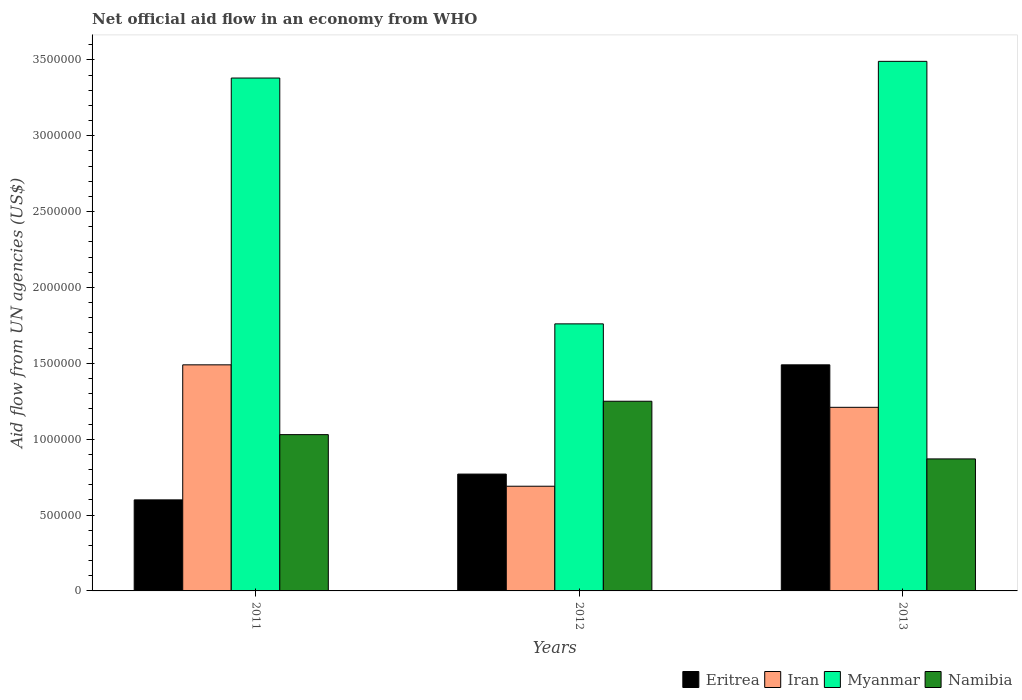Are the number of bars on each tick of the X-axis equal?
Give a very brief answer. Yes. How many bars are there on the 2nd tick from the left?
Provide a succinct answer. 4. How many bars are there on the 3rd tick from the right?
Offer a terse response. 4. In how many cases, is the number of bars for a given year not equal to the number of legend labels?
Ensure brevity in your answer.  0. What is the net official aid flow in Myanmar in 2013?
Your response must be concise. 3.49e+06. Across all years, what is the maximum net official aid flow in Myanmar?
Offer a very short reply. 3.49e+06. Across all years, what is the minimum net official aid flow in Iran?
Your answer should be very brief. 6.90e+05. In which year was the net official aid flow in Eritrea maximum?
Keep it short and to the point. 2013. What is the total net official aid flow in Namibia in the graph?
Give a very brief answer. 3.15e+06. What is the difference between the net official aid flow in Namibia in 2011 and that in 2012?
Keep it short and to the point. -2.20e+05. What is the average net official aid flow in Myanmar per year?
Keep it short and to the point. 2.88e+06. In the year 2012, what is the difference between the net official aid flow in Eritrea and net official aid flow in Myanmar?
Provide a short and direct response. -9.90e+05. In how many years, is the net official aid flow in Iran greater than 2800000 US$?
Give a very brief answer. 0. What is the ratio of the net official aid flow in Eritrea in 2012 to that in 2013?
Your response must be concise. 0.52. Is the difference between the net official aid flow in Eritrea in 2011 and 2012 greater than the difference between the net official aid flow in Myanmar in 2011 and 2012?
Your response must be concise. No. What is the difference between the highest and the lowest net official aid flow in Eritrea?
Offer a terse response. 8.90e+05. Is the sum of the net official aid flow in Namibia in 2011 and 2012 greater than the maximum net official aid flow in Iran across all years?
Provide a short and direct response. Yes. What does the 1st bar from the left in 2013 represents?
Your answer should be very brief. Eritrea. What does the 3rd bar from the right in 2013 represents?
Your response must be concise. Iran. Is it the case that in every year, the sum of the net official aid flow in Namibia and net official aid flow in Myanmar is greater than the net official aid flow in Iran?
Make the answer very short. Yes. How many bars are there?
Your answer should be compact. 12. Are all the bars in the graph horizontal?
Provide a succinct answer. No. How many years are there in the graph?
Offer a very short reply. 3. Does the graph contain any zero values?
Give a very brief answer. No. Does the graph contain grids?
Make the answer very short. No. How many legend labels are there?
Give a very brief answer. 4. How are the legend labels stacked?
Your answer should be very brief. Horizontal. What is the title of the graph?
Your response must be concise. Net official aid flow in an economy from WHO. What is the label or title of the Y-axis?
Your answer should be very brief. Aid flow from UN agencies (US$). What is the Aid flow from UN agencies (US$) of Iran in 2011?
Provide a short and direct response. 1.49e+06. What is the Aid flow from UN agencies (US$) in Myanmar in 2011?
Ensure brevity in your answer.  3.38e+06. What is the Aid flow from UN agencies (US$) of Namibia in 2011?
Your response must be concise. 1.03e+06. What is the Aid flow from UN agencies (US$) of Eritrea in 2012?
Your response must be concise. 7.70e+05. What is the Aid flow from UN agencies (US$) in Iran in 2012?
Offer a very short reply. 6.90e+05. What is the Aid flow from UN agencies (US$) of Myanmar in 2012?
Your answer should be compact. 1.76e+06. What is the Aid flow from UN agencies (US$) in Namibia in 2012?
Your answer should be very brief. 1.25e+06. What is the Aid flow from UN agencies (US$) of Eritrea in 2013?
Give a very brief answer. 1.49e+06. What is the Aid flow from UN agencies (US$) in Iran in 2013?
Provide a succinct answer. 1.21e+06. What is the Aid flow from UN agencies (US$) in Myanmar in 2013?
Offer a terse response. 3.49e+06. What is the Aid flow from UN agencies (US$) in Namibia in 2013?
Offer a very short reply. 8.70e+05. Across all years, what is the maximum Aid flow from UN agencies (US$) in Eritrea?
Ensure brevity in your answer.  1.49e+06. Across all years, what is the maximum Aid flow from UN agencies (US$) in Iran?
Provide a short and direct response. 1.49e+06. Across all years, what is the maximum Aid flow from UN agencies (US$) of Myanmar?
Offer a terse response. 3.49e+06. Across all years, what is the maximum Aid flow from UN agencies (US$) in Namibia?
Offer a very short reply. 1.25e+06. Across all years, what is the minimum Aid flow from UN agencies (US$) in Iran?
Offer a very short reply. 6.90e+05. Across all years, what is the minimum Aid flow from UN agencies (US$) in Myanmar?
Your answer should be very brief. 1.76e+06. Across all years, what is the minimum Aid flow from UN agencies (US$) in Namibia?
Offer a very short reply. 8.70e+05. What is the total Aid flow from UN agencies (US$) in Eritrea in the graph?
Your answer should be compact. 2.86e+06. What is the total Aid flow from UN agencies (US$) in Iran in the graph?
Provide a short and direct response. 3.39e+06. What is the total Aid flow from UN agencies (US$) in Myanmar in the graph?
Your answer should be very brief. 8.63e+06. What is the total Aid flow from UN agencies (US$) of Namibia in the graph?
Make the answer very short. 3.15e+06. What is the difference between the Aid flow from UN agencies (US$) of Iran in 2011 and that in 2012?
Your response must be concise. 8.00e+05. What is the difference between the Aid flow from UN agencies (US$) of Myanmar in 2011 and that in 2012?
Offer a terse response. 1.62e+06. What is the difference between the Aid flow from UN agencies (US$) in Eritrea in 2011 and that in 2013?
Your response must be concise. -8.90e+05. What is the difference between the Aid flow from UN agencies (US$) in Iran in 2011 and that in 2013?
Give a very brief answer. 2.80e+05. What is the difference between the Aid flow from UN agencies (US$) in Myanmar in 2011 and that in 2013?
Your answer should be very brief. -1.10e+05. What is the difference between the Aid flow from UN agencies (US$) in Eritrea in 2012 and that in 2013?
Make the answer very short. -7.20e+05. What is the difference between the Aid flow from UN agencies (US$) of Iran in 2012 and that in 2013?
Keep it short and to the point. -5.20e+05. What is the difference between the Aid flow from UN agencies (US$) of Myanmar in 2012 and that in 2013?
Your response must be concise. -1.73e+06. What is the difference between the Aid flow from UN agencies (US$) of Eritrea in 2011 and the Aid flow from UN agencies (US$) of Myanmar in 2012?
Provide a short and direct response. -1.16e+06. What is the difference between the Aid flow from UN agencies (US$) in Eritrea in 2011 and the Aid flow from UN agencies (US$) in Namibia in 2012?
Your answer should be compact. -6.50e+05. What is the difference between the Aid flow from UN agencies (US$) of Iran in 2011 and the Aid flow from UN agencies (US$) of Myanmar in 2012?
Your response must be concise. -2.70e+05. What is the difference between the Aid flow from UN agencies (US$) of Iran in 2011 and the Aid flow from UN agencies (US$) of Namibia in 2012?
Provide a succinct answer. 2.40e+05. What is the difference between the Aid flow from UN agencies (US$) in Myanmar in 2011 and the Aid flow from UN agencies (US$) in Namibia in 2012?
Provide a short and direct response. 2.13e+06. What is the difference between the Aid flow from UN agencies (US$) in Eritrea in 2011 and the Aid flow from UN agencies (US$) in Iran in 2013?
Offer a very short reply. -6.10e+05. What is the difference between the Aid flow from UN agencies (US$) in Eritrea in 2011 and the Aid flow from UN agencies (US$) in Myanmar in 2013?
Your response must be concise. -2.89e+06. What is the difference between the Aid flow from UN agencies (US$) in Eritrea in 2011 and the Aid flow from UN agencies (US$) in Namibia in 2013?
Your response must be concise. -2.70e+05. What is the difference between the Aid flow from UN agencies (US$) of Iran in 2011 and the Aid flow from UN agencies (US$) of Myanmar in 2013?
Give a very brief answer. -2.00e+06. What is the difference between the Aid flow from UN agencies (US$) in Iran in 2011 and the Aid flow from UN agencies (US$) in Namibia in 2013?
Give a very brief answer. 6.20e+05. What is the difference between the Aid flow from UN agencies (US$) of Myanmar in 2011 and the Aid flow from UN agencies (US$) of Namibia in 2013?
Keep it short and to the point. 2.51e+06. What is the difference between the Aid flow from UN agencies (US$) in Eritrea in 2012 and the Aid flow from UN agencies (US$) in Iran in 2013?
Your response must be concise. -4.40e+05. What is the difference between the Aid flow from UN agencies (US$) of Eritrea in 2012 and the Aid flow from UN agencies (US$) of Myanmar in 2013?
Offer a very short reply. -2.72e+06. What is the difference between the Aid flow from UN agencies (US$) of Iran in 2012 and the Aid flow from UN agencies (US$) of Myanmar in 2013?
Your answer should be very brief. -2.80e+06. What is the difference between the Aid flow from UN agencies (US$) of Myanmar in 2012 and the Aid flow from UN agencies (US$) of Namibia in 2013?
Provide a succinct answer. 8.90e+05. What is the average Aid flow from UN agencies (US$) of Eritrea per year?
Give a very brief answer. 9.53e+05. What is the average Aid flow from UN agencies (US$) in Iran per year?
Give a very brief answer. 1.13e+06. What is the average Aid flow from UN agencies (US$) of Myanmar per year?
Offer a terse response. 2.88e+06. What is the average Aid flow from UN agencies (US$) of Namibia per year?
Provide a short and direct response. 1.05e+06. In the year 2011, what is the difference between the Aid flow from UN agencies (US$) in Eritrea and Aid flow from UN agencies (US$) in Iran?
Ensure brevity in your answer.  -8.90e+05. In the year 2011, what is the difference between the Aid flow from UN agencies (US$) of Eritrea and Aid flow from UN agencies (US$) of Myanmar?
Your response must be concise. -2.78e+06. In the year 2011, what is the difference between the Aid flow from UN agencies (US$) of Eritrea and Aid flow from UN agencies (US$) of Namibia?
Make the answer very short. -4.30e+05. In the year 2011, what is the difference between the Aid flow from UN agencies (US$) of Iran and Aid flow from UN agencies (US$) of Myanmar?
Give a very brief answer. -1.89e+06. In the year 2011, what is the difference between the Aid flow from UN agencies (US$) of Myanmar and Aid flow from UN agencies (US$) of Namibia?
Your response must be concise. 2.35e+06. In the year 2012, what is the difference between the Aid flow from UN agencies (US$) in Eritrea and Aid flow from UN agencies (US$) in Iran?
Your answer should be compact. 8.00e+04. In the year 2012, what is the difference between the Aid flow from UN agencies (US$) of Eritrea and Aid flow from UN agencies (US$) of Myanmar?
Make the answer very short. -9.90e+05. In the year 2012, what is the difference between the Aid flow from UN agencies (US$) in Eritrea and Aid flow from UN agencies (US$) in Namibia?
Your response must be concise. -4.80e+05. In the year 2012, what is the difference between the Aid flow from UN agencies (US$) in Iran and Aid flow from UN agencies (US$) in Myanmar?
Give a very brief answer. -1.07e+06. In the year 2012, what is the difference between the Aid flow from UN agencies (US$) of Iran and Aid flow from UN agencies (US$) of Namibia?
Provide a short and direct response. -5.60e+05. In the year 2012, what is the difference between the Aid flow from UN agencies (US$) in Myanmar and Aid flow from UN agencies (US$) in Namibia?
Ensure brevity in your answer.  5.10e+05. In the year 2013, what is the difference between the Aid flow from UN agencies (US$) of Eritrea and Aid flow from UN agencies (US$) of Myanmar?
Your response must be concise. -2.00e+06. In the year 2013, what is the difference between the Aid flow from UN agencies (US$) in Eritrea and Aid flow from UN agencies (US$) in Namibia?
Your response must be concise. 6.20e+05. In the year 2013, what is the difference between the Aid flow from UN agencies (US$) of Iran and Aid flow from UN agencies (US$) of Myanmar?
Provide a succinct answer. -2.28e+06. In the year 2013, what is the difference between the Aid flow from UN agencies (US$) of Iran and Aid flow from UN agencies (US$) of Namibia?
Provide a short and direct response. 3.40e+05. In the year 2013, what is the difference between the Aid flow from UN agencies (US$) of Myanmar and Aid flow from UN agencies (US$) of Namibia?
Make the answer very short. 2.62e+06. What is the ratio of the Aid flow from UN agencies (US$) in Eritrea in 2011 to that in 2012?
Make the answer very short. 0.78. What is the ratio of the Aid flow from UN agencies (US$) in Iran in 2011 to that in 2012?
Ensure brevity in your answer.  2.16. What is the ratio of the Aid flow from UN agencies (US$) of Myanmar in 2011 to that in 2012?
Ensure brevity in your answer.  1.92. What is the ratio of the Aid flow from UN agencies (US$) of Namibia in 2011 to that in 2012?
Make the answer very short. 0.82. What is the ratio of the Aid flow from UN agencies (US$) in Eritrea in 2011 to that in 2013?
Your answer should be very brief. 0.4. What is the ratio of the Aid flow from UN agencies (US$) of Iran in 2011 to that in 2013?
Offer a terse response. 1.23. What is the ratio of the Aid flow from UN agencies (US$) of Myanmar in 2011 to that in 2013?
Your response must be concise. 0.97. What is the ratio of the Aid flow from UN agencies (US$) in Namibia in 2011 to that in 2013?
Your answer should be very brief. 1.18. What is the ratio of the Aid flow from UN agencies (US$) in Eritrea in 2012 to that in 2013?
Keep it short and to the point. 0.52. What is the ratio of the Aid flow from UN agencies (US$) in Iran in 2012 to that in 2013?
Keep it short and to the point. 0.57. What is the ratio of the Aid flow from UN agencies (US$) in Myanmar in 2012 to that in 2013?
Ensure brevity in your answer.  0.5. What is the ratio of the Aid flow from UN agencies (US$) in Namibia in 2012 to that in 2013?
Your response must be concise. 1.44. What is the difference between the highest and the second highest Aid flow from UN agencies (US$) of Eritrea?
Offer a terse response. 7.20e+05. What is the difference between the highest and the second highest Aid flow from UN agencies (US$) in Iran?
Keep it short and to the point. 2.80e+05. What is the difference between the highest and the second highest Aid flow from UN agencies (US$) in Myanmar?
Your response must be concise. 1.10e+05. What is the difference between the highest and the second highest Aid flow from UN agencies (US$) of Namibia?
Offer a terse response. 2.20e+05. What is the difference between the highest and the lowest Aid flow from UN agencies (US$) of Eritrea?
Provide a short and direct response. 8.90e+05. What is the difference between the highest and the lowest Aid flow from UN agencies (US$) of Iran?
Offer a terse response. 8.00e+05. What is the difference between the highest and the lowest Aid flow from UN agencies (US$) of Myanmar?
Your answer should be compact. 1.73e+06. What is the difference between the highest and the lowest Aid flow from UN agencies (US$) of Namibia?
Your answer should be very brief. 3.80e+05. 